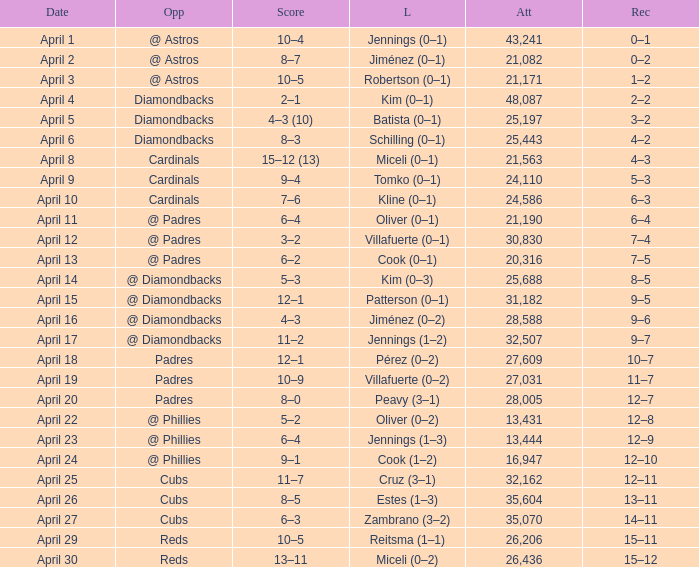Who is the opponent on april 16? @ Diamondbacks. 